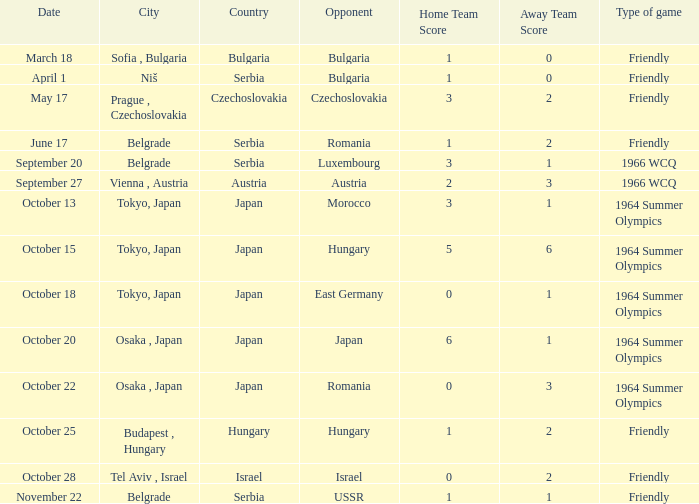What was the result for the 1964 summer olympics on october 18? 0:1. Could you help me parse every detail presented in this table? {'header': ['Date', 'City', 'Country', 'Opponent', 'Home Team Score', 'Away Team Score', 'Type of game'], 'rows': [['March 18', 'Sofia , Bulgaria', 'Bulgaria', 'Bulgaria', '1', '0', 'Friendly'], ['April 1', 'Niš', 'Serbia', 'Bulgaria', '1', '0', 'Friendly'], ['May 17', 'Prague , Czechoslovakia', 'Czechoslovakia', 'Czechoslovakia', '3', '2', 'Friendly'], ['June 17', 'Belgrade', 'Serbia', 'Romania', '1', '2', 'Friendly'], ['September 20', 'Belgrade', 'Serbia', 'Luxembourg', '3', '1', '1966 WCQ'], ['September 27', 'Vienna , Austria', 'Austria', 'Austria', '2', '3', '1966 WCQ'], ['October 13', 'Tokyo, Japan', 'Japan', 'Morocco', '3', '1', '1964 Summer Olympics'], ['October 15', 'Tokyo, Japan', 'Japan', 'Hungary', '5', '6', '1964 Summer Olympics'], ['October 18', 'Tokyo, Japan', 'Japan', 'East Germany', '0', '1', '1964 Summer Olympics'], ['October 20', 'Osaka , Japan', 'Japan', 'Japan', '6', '1', '1964 Summer Olympics'], ['October 22', 'Osaka , Japan', 'Japan', 'Romania', '0', '3', '1964 Summer Olympics'], ['October 25', 'Budapest , Hungary', 'Hungary', 'Hungary', '1', '2', 'Friendly'], ['October 28', 'Tel Aviv , Israel', 'Israel', 'Israel', '0', '2', 'Friendly'], ['November 22', 'Belgrade', 'Serbia', 'USSR', '1', '1', 'Friendly']]} 